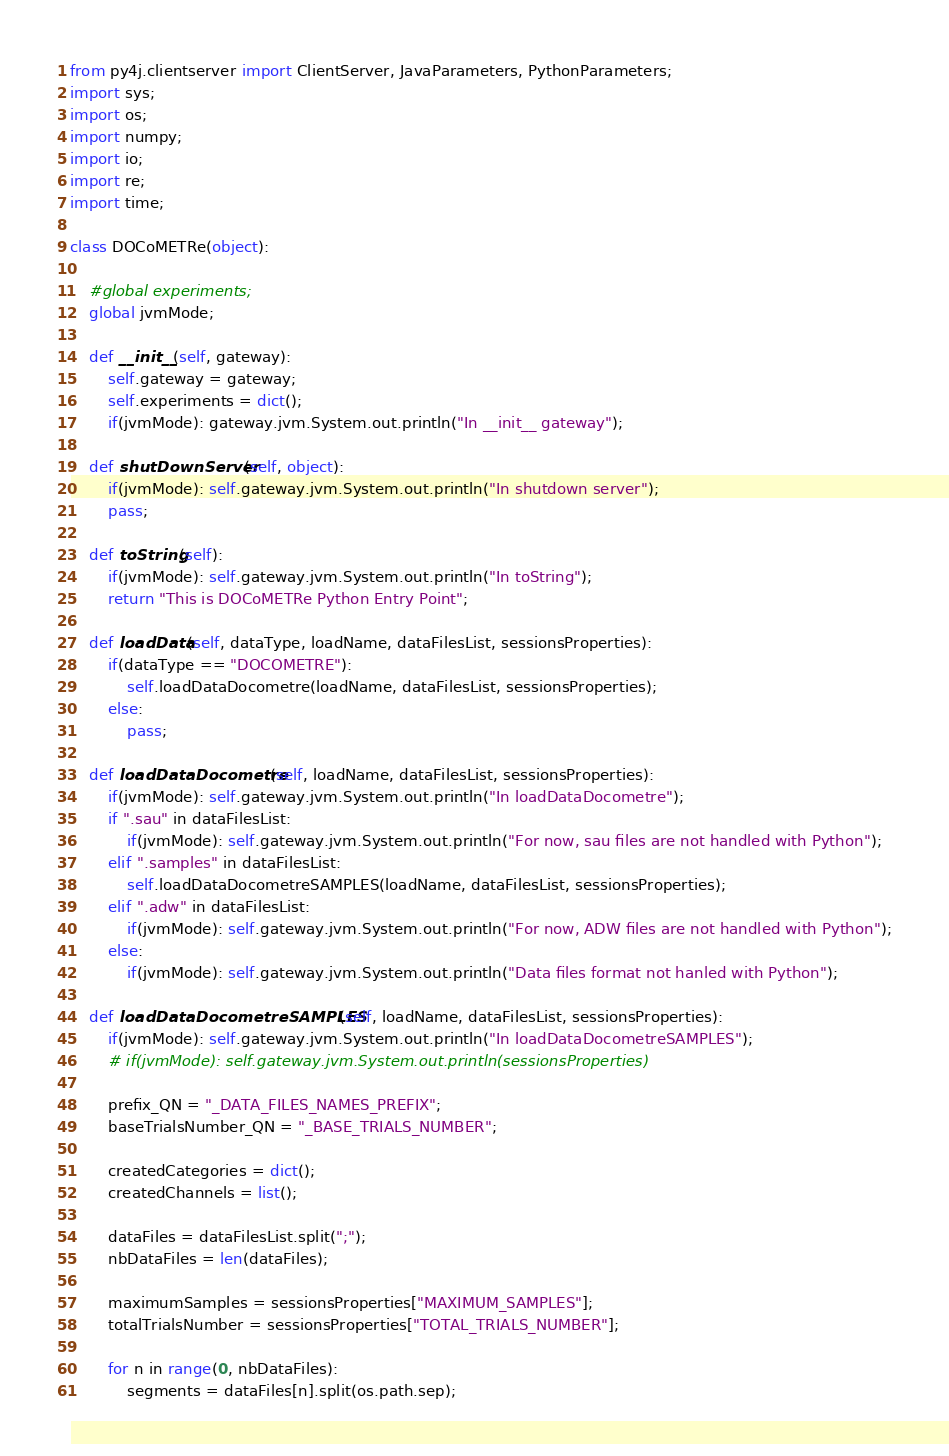<code> <loc_0><loc_0><loc_500><loc_500><_Python_>from py4j.clientserver import ClientServer, JavaParameters, PythonParameters;
import sys;
import os;
import numpy;
import io;
import re;
import time;

class DOCoMETRe(object):

	#global experiments;
	global jvmMode;

	def __init__(self, gateway):
	 	self.gateway = gateway;
	 	self.experiments = dict();
	 	if(jvmMode): gateway.jvm.System.out.println("In __init__ gateway");

	def shutDownServer(self, object):
		if(jvmMode): self.gateway.jvm.System.out.println("In shutdown server");
		pass;

	def toString(self):
		if(jvmMode): self.gateway.jvm.System.out.println("In toString");
		return "This is DOCoMETRe Python Entry Point";

	def loadData(self, dataType, loadName, dataFilesList, sessionsProperties):
		if(dataType == "DOCOMETRE"):
			self.loadDataDocometre(loadName, dataFilesList, sessionsProperties);
		else:
			pass;

	def loadDataDocometre(self, loadName, dataFilesList, sessionsProperties):
		if(jvmMode): self.gateway.jvm.System.out.println("In loadDataDocometre");
		if ".sau" in dataFilesList:
			if(jvmMode): self.gateway.jvm.System.out.println("For now, sau files are not handled with Python");
		elif ".samples" in dataFilesList:
			self.loadDataDocometreSAMPLES(loadName, dataFilesList, sessionsProperties);
		elif ".adw" in dataFilesList:
			if(jvmMode): self.gateway.jvm.System.out.println("For now, ADW files are not handled with Python");
		else:
			if(jvmMode): self.gateway.jvm.System.out.println("Data files format not hanled with Python");

	def loadDataDocometreSAMPLES(self, loadName, dataFilesList, sessionsProperties):
		if(jvmMode): self.gateway.jvm.System.out.println("In loadDataDocometreSAMPLES");
		# if(jvmMode): self.gateway.jvm.System.out.println(sessionsProperties)

		prefix_QN = "_DATA_FILES_NAMES_PREFIX";
		baseTrialsNumber_QN = "_BASE_TRIALS_NUMBER";

		createdCategories = dict();
		createdChannels = list();

		dataFiles = dataFilesList.split(";");
		nbDataFiles = len(dataFiles);

		maximumSamples = sessionsProperties["MAXIMUM_SAMPLES"];
		totalTrialsNumber = sessionsProperties["TOTAL_TRIALS_NUMBER"];

		for n in range(0, nbDataFiles):
			segments = dataFiles[n].split(os.path.sep);
</code> 